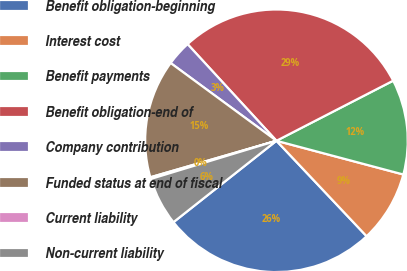<chart> <loc_0><loc_0><loc_500><loc_500><pie_chart><fcel>Benefit obligation-beginning<fcel>Interest cost<fcel>Benefit payments<fcel>Benefit obligation-end of<fcel>Company contribution<fcel>Funded status at end of fiscal<fcel>Current liability<fcel>Non-current liability<nl><fcel>26.4%<fcel>8.82%<fcel>11.7%<fcel>29.27%<fcel>3.08%<fcel>14.57%<fcel>0.21%<fcel>5.95%<nl></chart> 